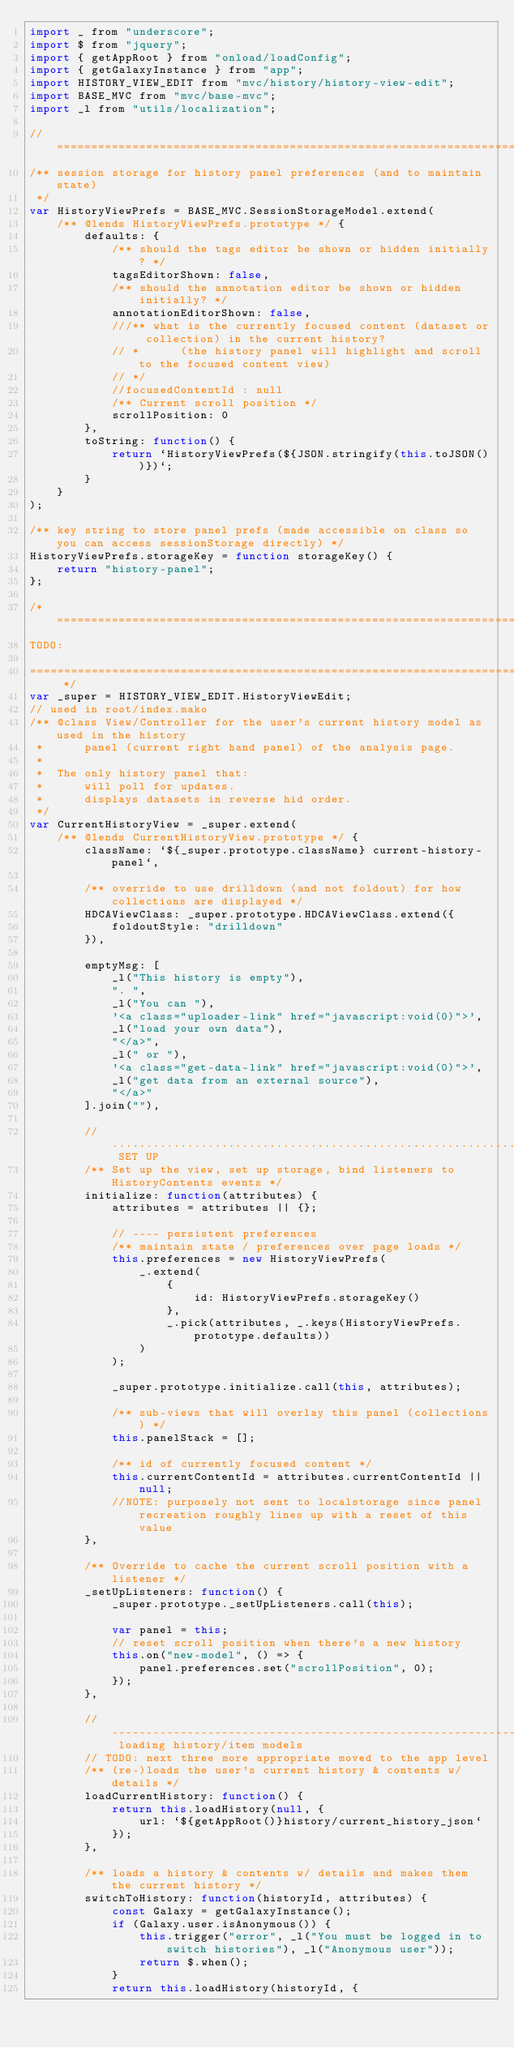<code> <loc_0><loc_0><loc_500><loc_500><_JavaScript_>import _ from "underscore";
import $ from "jquery";
import { getAppRoot } from "onload/loadConfig";
import { getGalaxyInstance } from "app";
import HISTORY_VIEW_EDIT from "mvc/history/history-view-edit";
import BASE_MVC from "mvc/base-mvc";
import _l from "utils/localization";

// ============================================================================
/** session storage for history panel preferences (and to maintain state)
 */
var HistoryViewPrefs = BASE_MVC.SessionStorageModel.extend(
    /** @lends HistoryViewPrefs.prototype */ {
        defaults: {
            /** should the tags editor be shown or hidden initially? */
            tagsEditorShown: false,
            /** should the annotation editor be shown or hidden initially? */
            annotationEditorShown: false,
            ///** what is the currently focused content (dataset or collection) in the current history?
            // *      (the history panel will highlight and scroll to the focused content view)
            // */
            //focusedContentId : null
            /** Current scroll position */
            scrollPosition: 0
        },
        toString: function() {
            return `HistoryViewPrefs(${JSON.stringify(this.toJSON())})`;
        }
    }
);

/** key string to store panel prefs (made accessible on class so you can access sessionStorage directly) */
HistoryViewPrefs.storageKey = function storageKey() {
    return "history-panel";
};

/* =============================================================================
TODO:

============================================================================= */
var _super = HISTORY_VIEW_EDIT.HistoryViewEdit;
// used in root/index.mako
/** @class View/Controller for the user's current history model as used in the history
 *      panel (current right hand panel) of the analysis page.
 *
 *  The only history panel that:
 *      will poll for updates.
 *      displays datasets in reverse hid order.
 */
var CurrentHistoryView = _super.extend(
    /** @lends CurrentHistoryView.prototype */ {
        className: `${_super.prototype.className} current-history-panel`,

        /** override to use drilldown (and not foldout) for how collections are displayed */
        HDCAViewClass: _super.prototype.HDCAViewClass.extend({
            foldoutStyle: "drilldown"
        }),

        emptyMsg: [
            _l("This history is empty"),
            ". ",
            _l("You can "),
            '<a class="uploader-link" href="javascript:void(0)">',
            _l("load your own data"),
            "</a>",
            _l(" or "),
            '<a class="get-data-link" href="javascript:void(0)">',
            _l("get data from an external source"),
            "</a>"
        ].join(""),

        // ......................................................................... SET UP
        /** Set up the view, set up storage, bind listeners to HistoryContents events */
        initialize: function(attributes) {
            attributes = attributes || {};

            // ---- persistent preferences
            /** maintain state / preferences over page loads */
            this.preferences = new HistoryViewPrefs(
                _.extend(
                    {
                        id: HistoryViewPrefs.storageKey()
                    },
                    _.pick(attributes, _.keys(HistoryViewPrefs.prototype.defaults))
                )
            );

            _super.prototype.initialize.call(this, attributes);

            /** sub-views that will overlay this panel (collections) */
            this.panelStack = [];

            /** id of currently focused content */
            this.currentContentId = attributes.currentContentId || null;
            //NOTE: purposely not sent to localstorage since panel recreation roughly lines up with a reset of this value
        },

        /** Override to cache the current scroll position with a listener */
        _setUpListeners: function() {
            _super.prototype._setUpListeners.call(this);

            var panel = this;
            // reset scroll position when there's a new history
            this.on("new-model", () => {
                panel.preferences.set("scrollPosition", 0);
            });
        },

        // ------------------------------------------------------------------------ loading history/item models
        // TODO: next three more appropriate moved to the app level
        /** (re-)loads the user's current history & contents w/ details */
        loadCurrentHistory: function() {
            return this.loadHistory(null, {
                url: `${getAppRoot()}history/current_history_json`
            });
        },

        /** loads a history & contents w/ details and makes them the current history */
        switchToHistory: function(historyId, attributes) {
            const Galaxy = getGalaxyInstance();
            if (Galaxy.user.isAnonymous()) {
                this.trigger("error", _l("You must be logged in to switch histories"), _l("Anonymous user"));
                return $.when();
            }
            return this.loadHistory(historyId, {</code> 